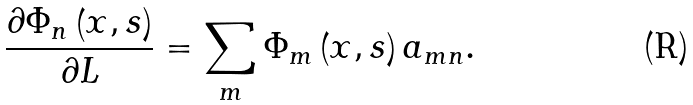<formula> <loc_0><loc_0><loc_500><loc_500>\frac { \partial \Phi _ { n } \left ( x , s \right ) } { \partial L } = \sum _ { m } \Phi _ { m } \left ( x , s \right ) a _ { m n } .</formula> 